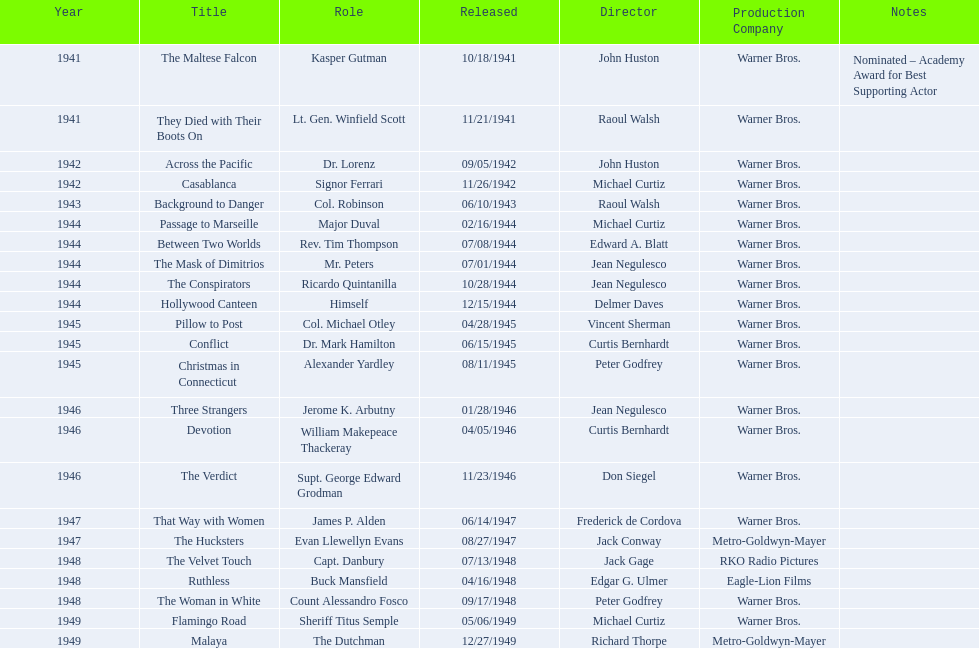How many cinematic works has he participated in from 1941 to 1949? 23. 